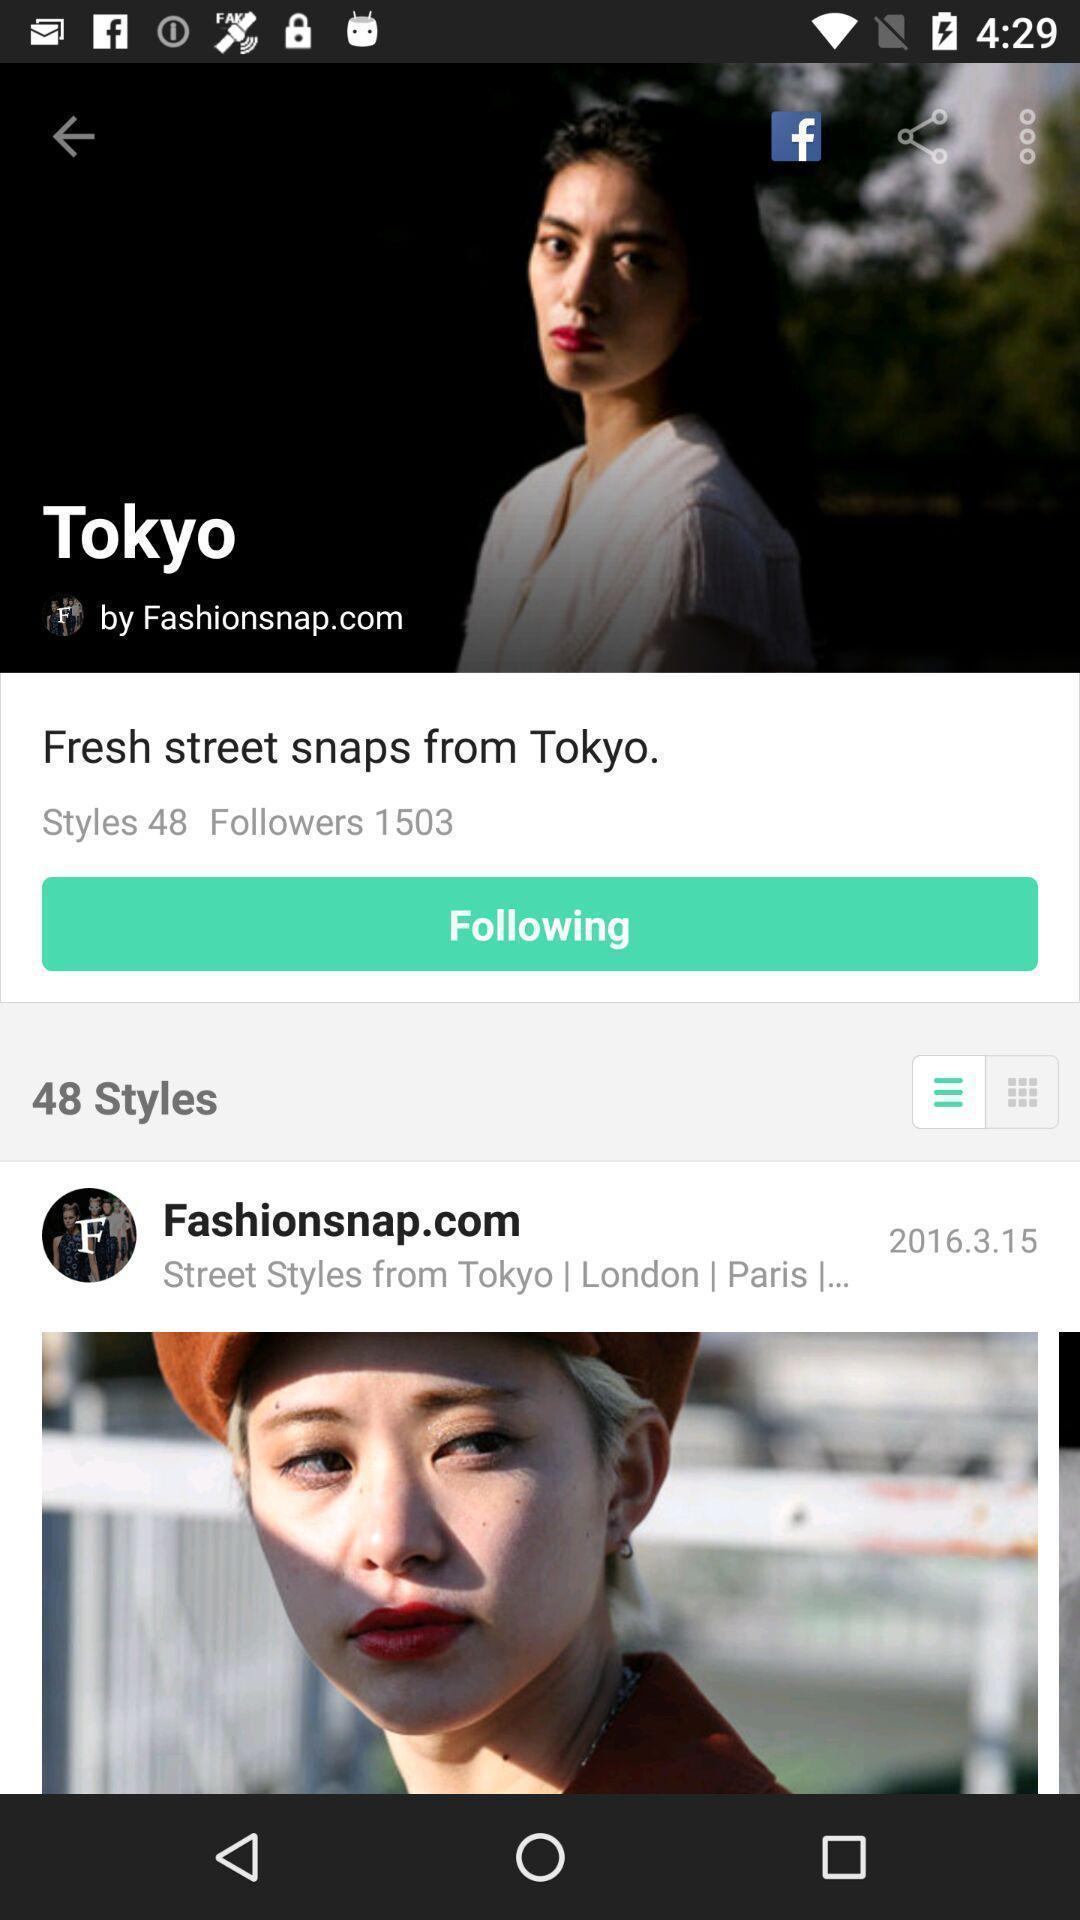What is the overall content of this screenshot? Various feed displayed in a fashion styling app. 